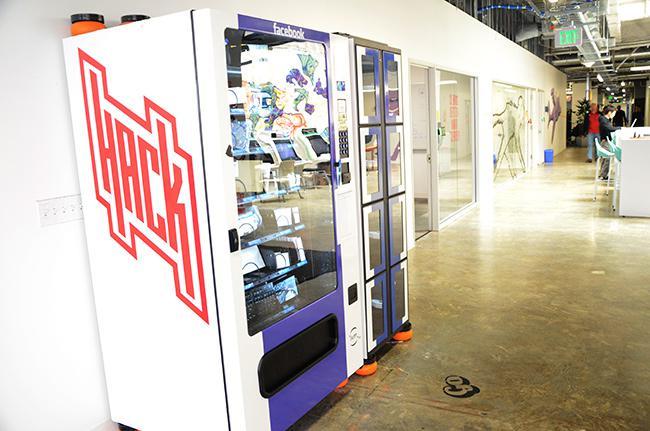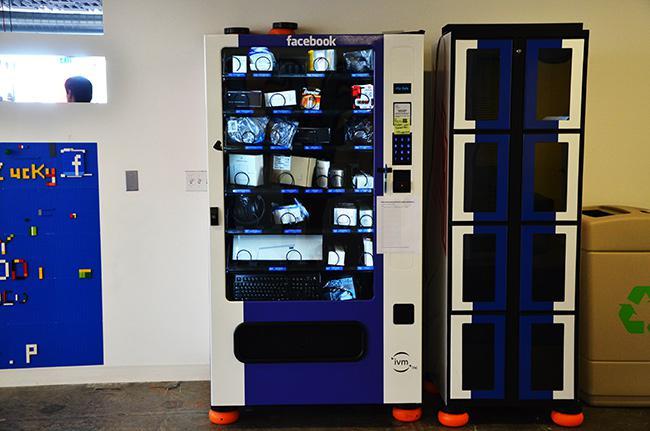The first image is the image on the left, the second image is the image on the right. Assess this claim about the two images: "Two people are shown at vending machines.". Correct or not? Answer yes or no. No. The first image is the image on the left, the second image is the image on the right. Given the left and right images, does the statement "Someone is touching a vending machine in the right image." hold true? Answer yes or no. No. 